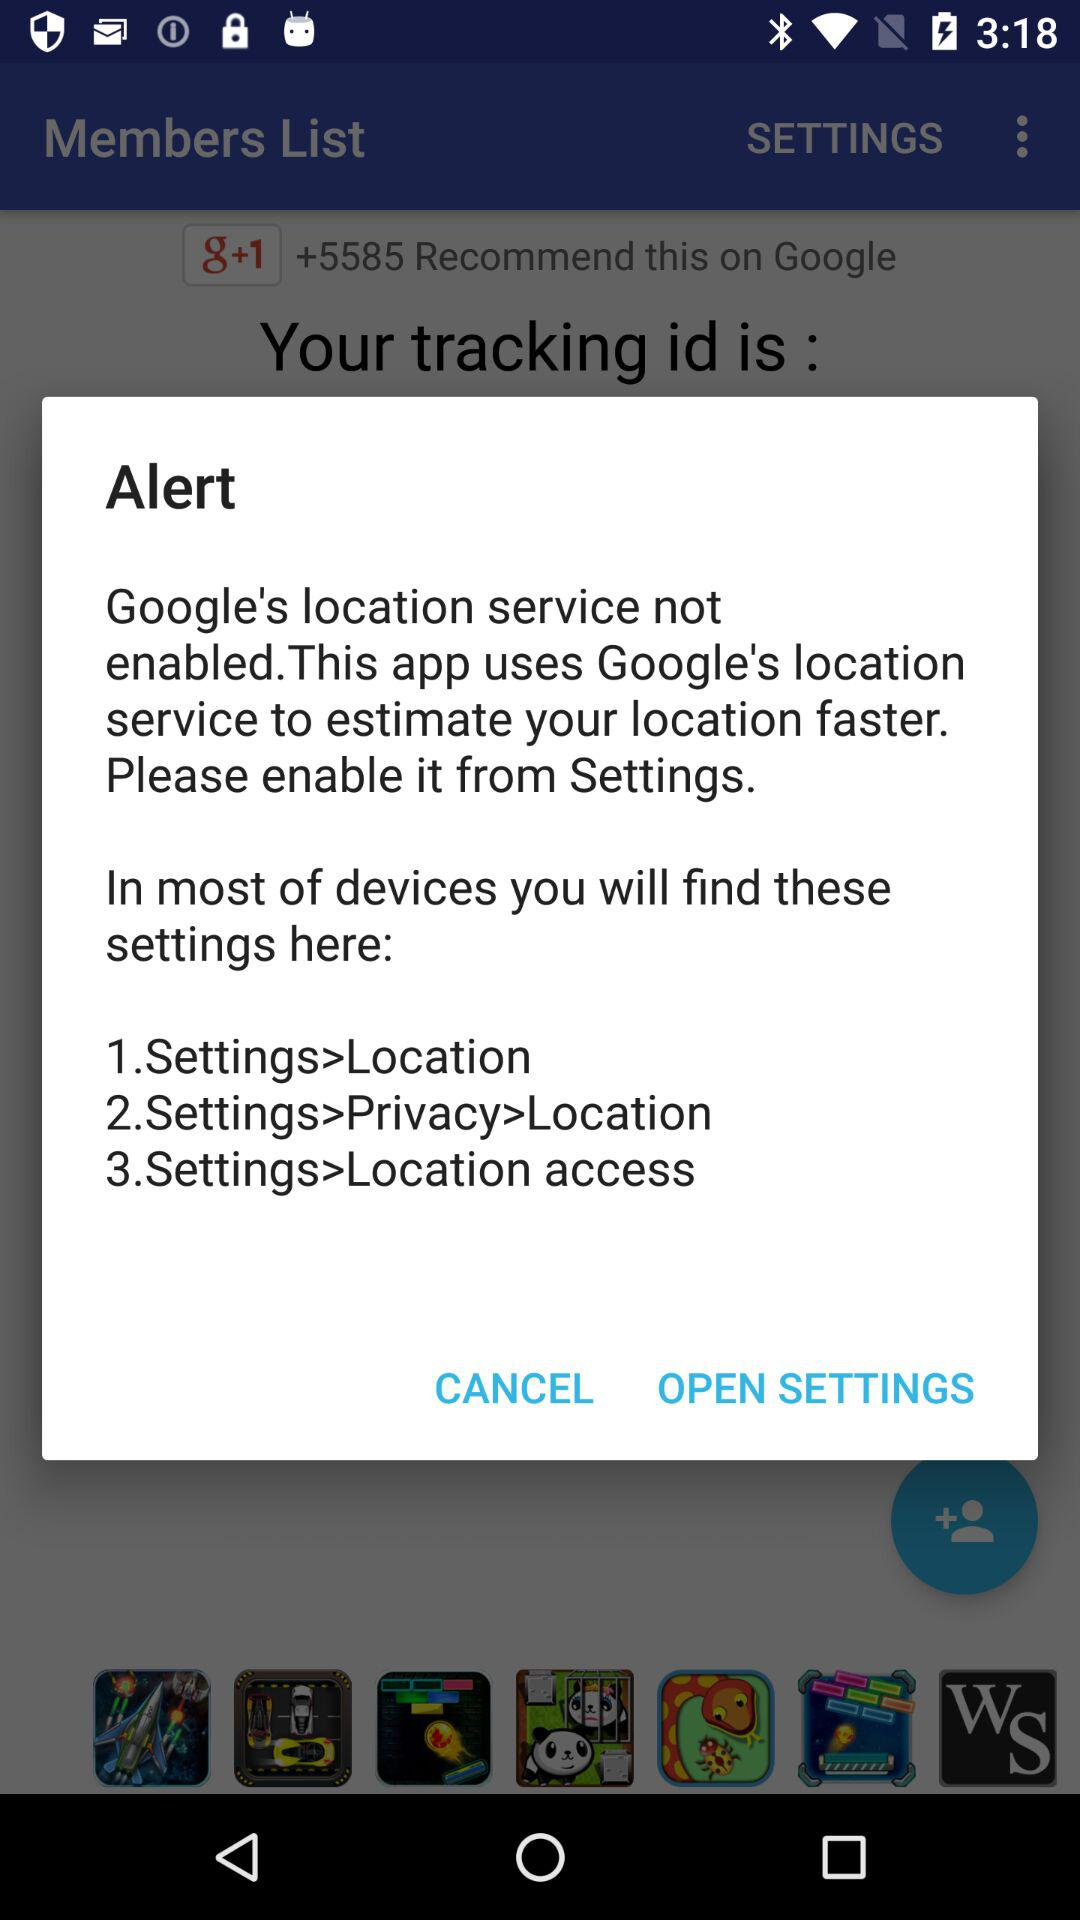How many steps are there to enable location services?
Answer the question using a single word or phrase. 3 